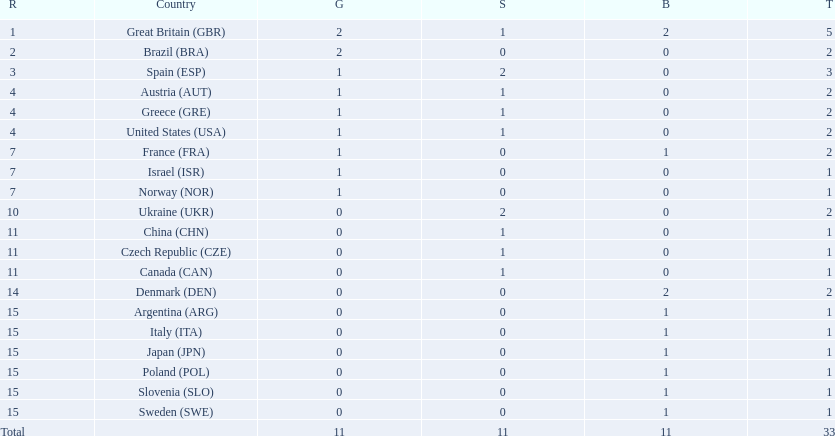What country had the most medals? Great Britain. Parse the full table. {'header': ['R', 'Country', 'G', 'S', 'B', 'T'], 'rows': [['1', 'Great Britain\xa0(GBR)', '2', '1', '2', '5'], ['2', 'Brazil\xa0(BRA)', '2', '0', '0', '2'], ['3', 'Spain\xa0(ESP)', '1', '2', '0', '3'], ['4', 'Austria\xa0(AUT)', '1', '1', '0', '2'], ['4', 'Greece\xa0(GRE)', '1', '1', '0', '2'], ['4', 'United States\xa0(USA)', '1', '1', '0', '2'], ['7', 'France\xa0(FRA)', '1', '0', '1', '2'], ['7', 'Israel\xa0(ISR)', '1', '0', '0', '1'], ['7', 'Norway\xa0(NOR)', '1', '0', '0', '1'], ['10', 'Ukraine\xa0(UKR)', '0', '2', '0', '2'], ['11', 'China\xa0(CHN)', '0', '1', '0', '1'], ['11', 'Czech Republic\xa0(CZE)', '0', '1', '0', '1'], ['11', 'Canada\xa0(CAN)', '0', '1', '0', '1'], ['14', 'Denmark\xa0(DEN)', '0', '0', '2', '2'], ['15', 'Argentina\xa0(ARG)', '0', '0', '1', '1'], ['15', 'Italy\xa0(ITA)', '0', '0', '1', '1'], ['15', 'Japan\xa0(JPN)', '0', '0', '1', '1'], ['15', 'Poland\xa0(POL)', '0', '0', '1', '1'], ['15', 'Slovenia\xa0(SLO)', '0', '0', '1', '1'], ['15', 'Sweden\xa0(SWE)', '0', '0', '1', '1'], ['Total', '', '11', '11', '11', '33']]} 